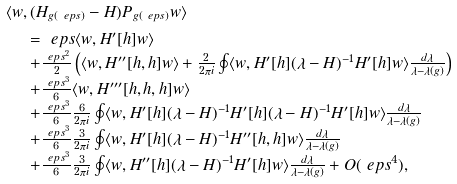<formula> <loc_0><loc_0><loc_500><loc_500>& \langle w , ( H _ { g ( \ e p s ) } - H ) P _ { g ( \ e p s ) } w \rangle \\ & \begin{array} { l } \quad = \ e p s \langle w , H ^ { \prime } [ h ] w \rangle \\ \quad + \frac { \ e p s ^ { 2 } } { 2 } \left ( \langle w , H ^ { \prime \prime } [ h , h ] w \rangle + \frac { 2 } { 2 \pi i } \oint \langle w , H ^ { \prime } [ h ] ( \lambda - H ) ^ { - 1 } H ^ { \prime } [ h ] w \rangle \frac { d \lambda } { \lambda - \lambda ( g ) } \right ) \\ \quad + \frac { \ e p s ^ { 3 } } { 6 } \langle w , H ^ { \prime \prime \prime } [ h , h , h ] w \rangle \\ \quad + \frac { \ e p s ^ { 3 } } { 6 } \frac { 6 } { 2 \pi i } \oint \langle w , H ^ { \prime } [ h ] ( \lambda - H ) ^ { - 1 } H ^ { \prime } [ h ] ( \lambda - H ) ^ { - 1 } H ^ { \prime } [ h ] w \rangle \frac { d \lambda } { \lambda - \lambda ( g ) } \\ \quad + \frac { \ e p s ^ { 3 } } { 6 } \frac { 3 } { 2 \pi i } \oint \langle w , H ^ { \prime } [ h ] ( \lambda - H ) ^ { - 1 } H ^ { \prime \prime } [ h , h ] w \rangle \frac { d \lambda } { \lambda - \lambda ( g ) } \\ \quad + \frac { \ e p s ^ { 3 } } { 6 } \frac { 3 } { 2 \pi i } \oint \langle w , H ^ { \prime \prime } [ h ] ( \lambda - H ) ^ { - 1 } H ^ { \prime } [ h ] w \rangle \frac { d \lambda } { \lambda - \lambda ( g ) } + O ( \ e p s ^ { 4 } ) , \end{array}</formula> 